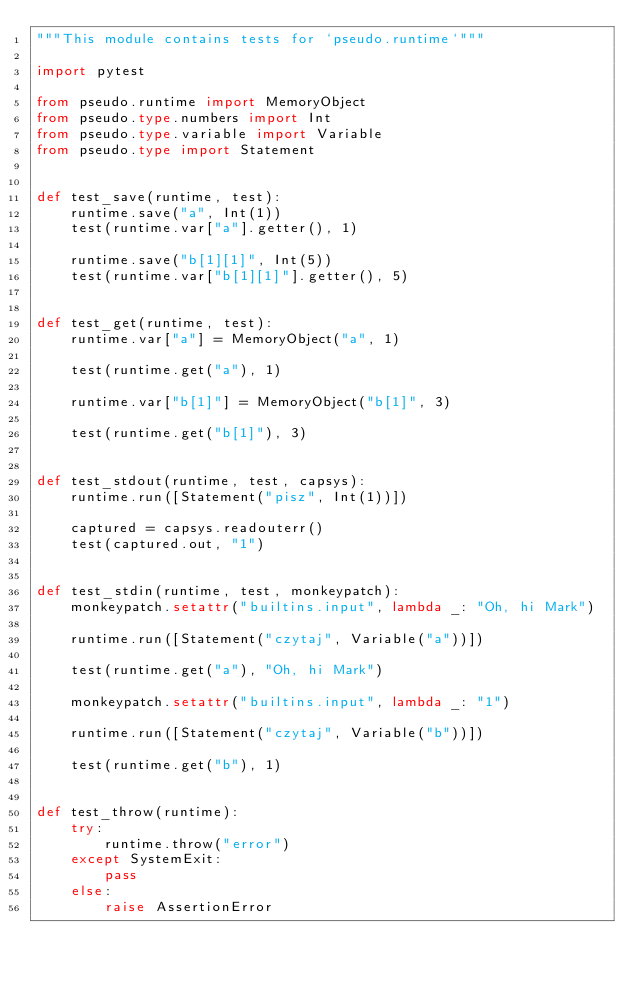Convert code to text. <code><loc_0><loc_0><loc_500><loc_500><_Python_>"""This module contains tests for `pseudo.runtime`"""

import pytest

from pseudo.runtime import MemoryObject
from pseudo.type.numbers import Int
from pseudo.type.variable import Variable
from pseudo.type import Statement


def test_save(runtime, test):
    runtime.save("a", Int(1))
    test(runtime.var["a"].getter(), 1)

    runtime.save("b[1][1]", Int(5))
    test(runtime.var["b[1][1]"].getter(), 5)


def test_get(runtime, test):
    runtime.var["a"] = MemoryObject("a", 1)

    test(runtime.get("a"), 1)

    runtime.var["b[1]"] = MemoryObject("b[1]", 3)

    test(runtime.get("b[1]"), 3)


def test_stdout(runtime, test, capsys):
    runtime.run([Statement("pisz", Int(1))])

    captured = capsys.readouterr()
    test(captured.out, "1")


def test_stdin(runtime, test, monkeypatch):
    monkeypatch.setattr("builtins.input", lambda _: "Oh, hi Mark")

    runtime.run([Statement("czytaj", Variable("a"))])

    test(runtime.get("a"), "Oh, hi Mark")

    monkeypatch.setattr("builtins.input", lambda _: "1")

    runtime.run([Statement("czytaj", Variable("b"))])

    test(runtime.get("b"), 1)


def test_throw(runtime):
    try:
        runtime.throw("error")
    except SystemExit:
        pass
    else:
        raise AssertionError
</code> 